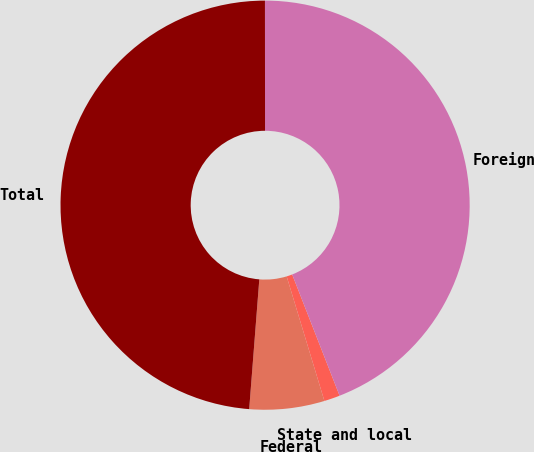Convert chart. <chart><loc_0><loc_0><loc_500><loc_500><pie_chart><fcel>Federal<fcel>State and local<fcel>Foreign<fcel>Total<nl><fcel>5.92%<fcel>1.25%<fcel>44.08%<fcel>48.75%<nl></chart> 